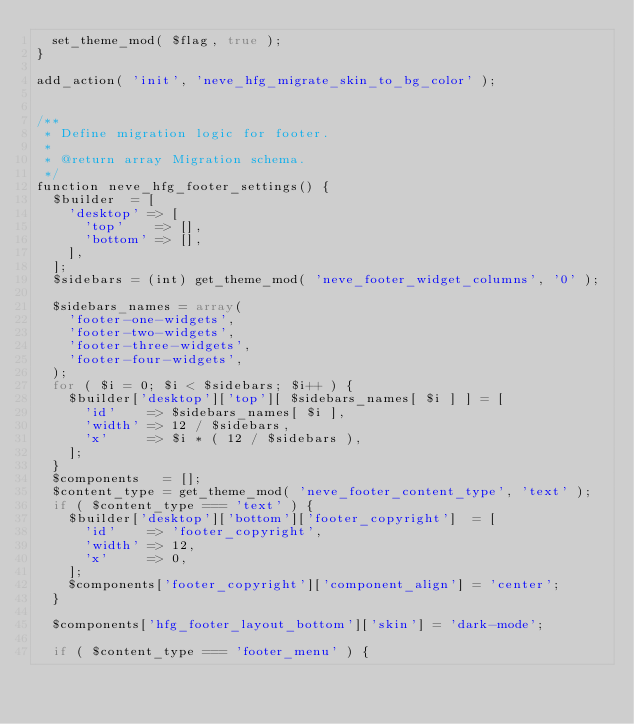<code> <loc_0><loc_0><loc_500><loc_500><_PHP_>	set_theme_mod( $flag, true );
}

add_action( 'init', 'neve_hfg_migrate_skin_to_bg_color' );


/**
 * Define migration logic for footer.
 *
 * @return array Migration schema.
 */
function neve_hfg_footer_settings() {
	$builder  = [
		'desktop' => [
			'top'    => [],
			'bottom' => [],
		],
	];
	$sidebars = (int) get_theme_mod( 'neve_footer_widget_columns', '0' );

	$sidebars_names = array(
		'footer-one-widgets',
		'footer-two-widgets',
		'footer-three-widgets',
		'footer-four-widgets',
	);
	for ( $i = 0; $i < $sidebars; $i++ ) {
		$builder['desktop']['top'][ $sidebars_names[ $i ] ] = [
			'id'    => $sidebars_names[ $i ],
			'width' => 12 / $sidebars,
			'x'     => $i * ( 12 / $sidebars ),
		];
	}
	$components   = [];
	$content_type = get_theme_mod( 'neve_footer_content_type', 'text' );
	if ( $content_type === 'text' ) {
		$builder['desktop']['bottom']['footer_copyright']  = [
			'id'    => 'footer_copyright',
			'width' => 12,
			'x'     => 0,
		];
		$components['footer_copyright']['component_align'] = 'center';
	}

	$components['hfg_footer_layout_bottom']['skin'] = 'dark-mode';

	if ( $content_type === 'footer_menu' ) {</code> 